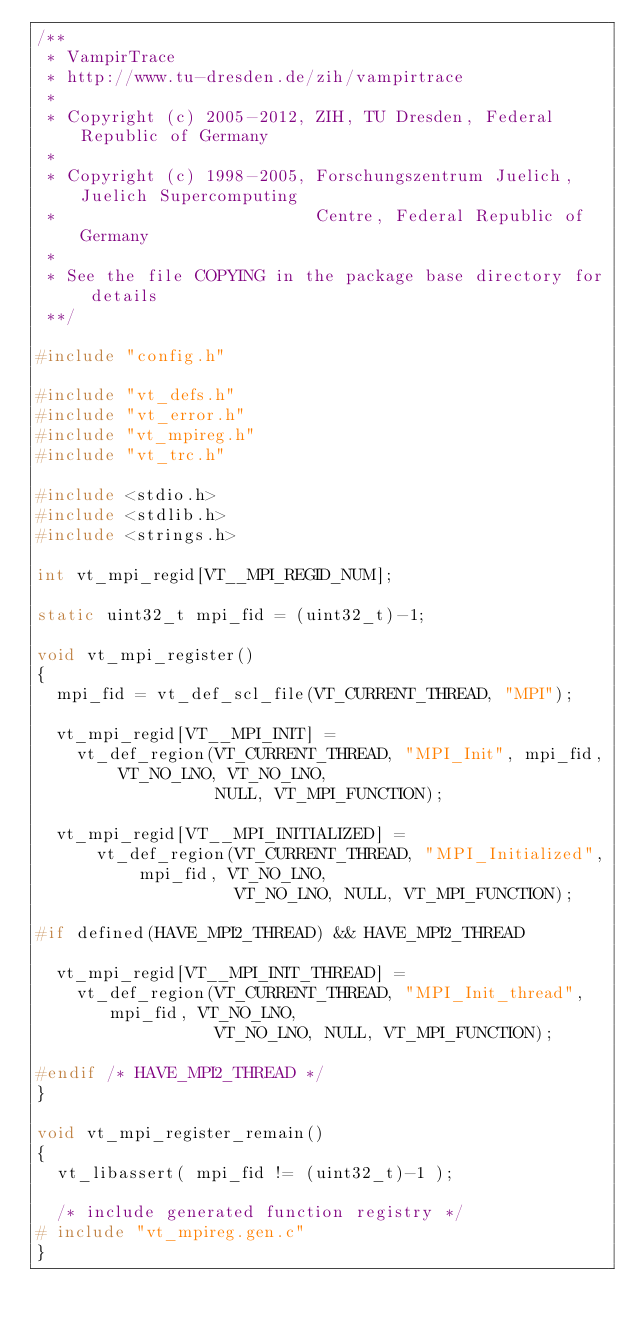Convert code to text. <code><loc_0><loc_0><loc_500><loc_500><_C_>/**
 * VampirTrace
 * http://www.tu-dresden.de/zih/vampirtrace
 *
 * Copyright (c) 2005-2012, ZIH, TU Dresden, Federal Republic of Germany
 *
 * Copyright (c) 1998-2005, Forschungszentrum Juelich, Juelich Supercomputing
 *                          Centre, Federal Republic of Germany
 *
 * See the file COPYING in the package base directory for details
 **/

#include "config.h"

#include "vt_defs.h"
#include "vt_error.h"
#include "vt_mpireg.h"
#include "vt_trc.h"

#include <stdio.h>
#include <stdlib.h>
#include <strings.h>

int vt_mpi_regid[VT__MPI_REGID_NUM];

static uint32_t mpi_fid = (uint32_t)-1;

void vt_mpi_register()
{
  mpi_fid = vt_def_scl_file(VT_CURRENT_THREAD, "MPI");

  vt_mpi_regid[VT__MPI_INIT] =
    vt_def_region(VT_CURRENT_THREAD, "MPI_Init", mpi_fid, VT_NO_LNO, VT_NO_LNO,
                  NULL, VT_MPI_FUNCTION);

  vt_mpi_regid[VT__MPI_INITIALIZED] =
      vt_def_region(VT_CURRENT_THREAD, "MPI_Initialized", mpi_fid, VT_NO_LNO,
                    VT_NO_LNO, NULL, VT_MPI_FUNCTION);

#if defined(HAVE_MPI2_THREAD) && HAVE_MPI2_THREAD

  vt_mpi_regid[VT__MPI_INIT_THREAD] =
    vt_def_region(VT_CURRENT_THREAD, "MPI_Init_thread", mpi_fid, VT_NO_LNO,
                  VT_NO_LNO, NULL, VT_MPI_FUNCTION);

#endif /* HAVE_MPI2_THREAD */
}

void vt_mpi_register_remain()
{
  vt_libassert( mpi_fid != (uint32_t)-1 );

  /* include generated function registry */
# include "vt_mpireg.gen.c"
}
</code> 